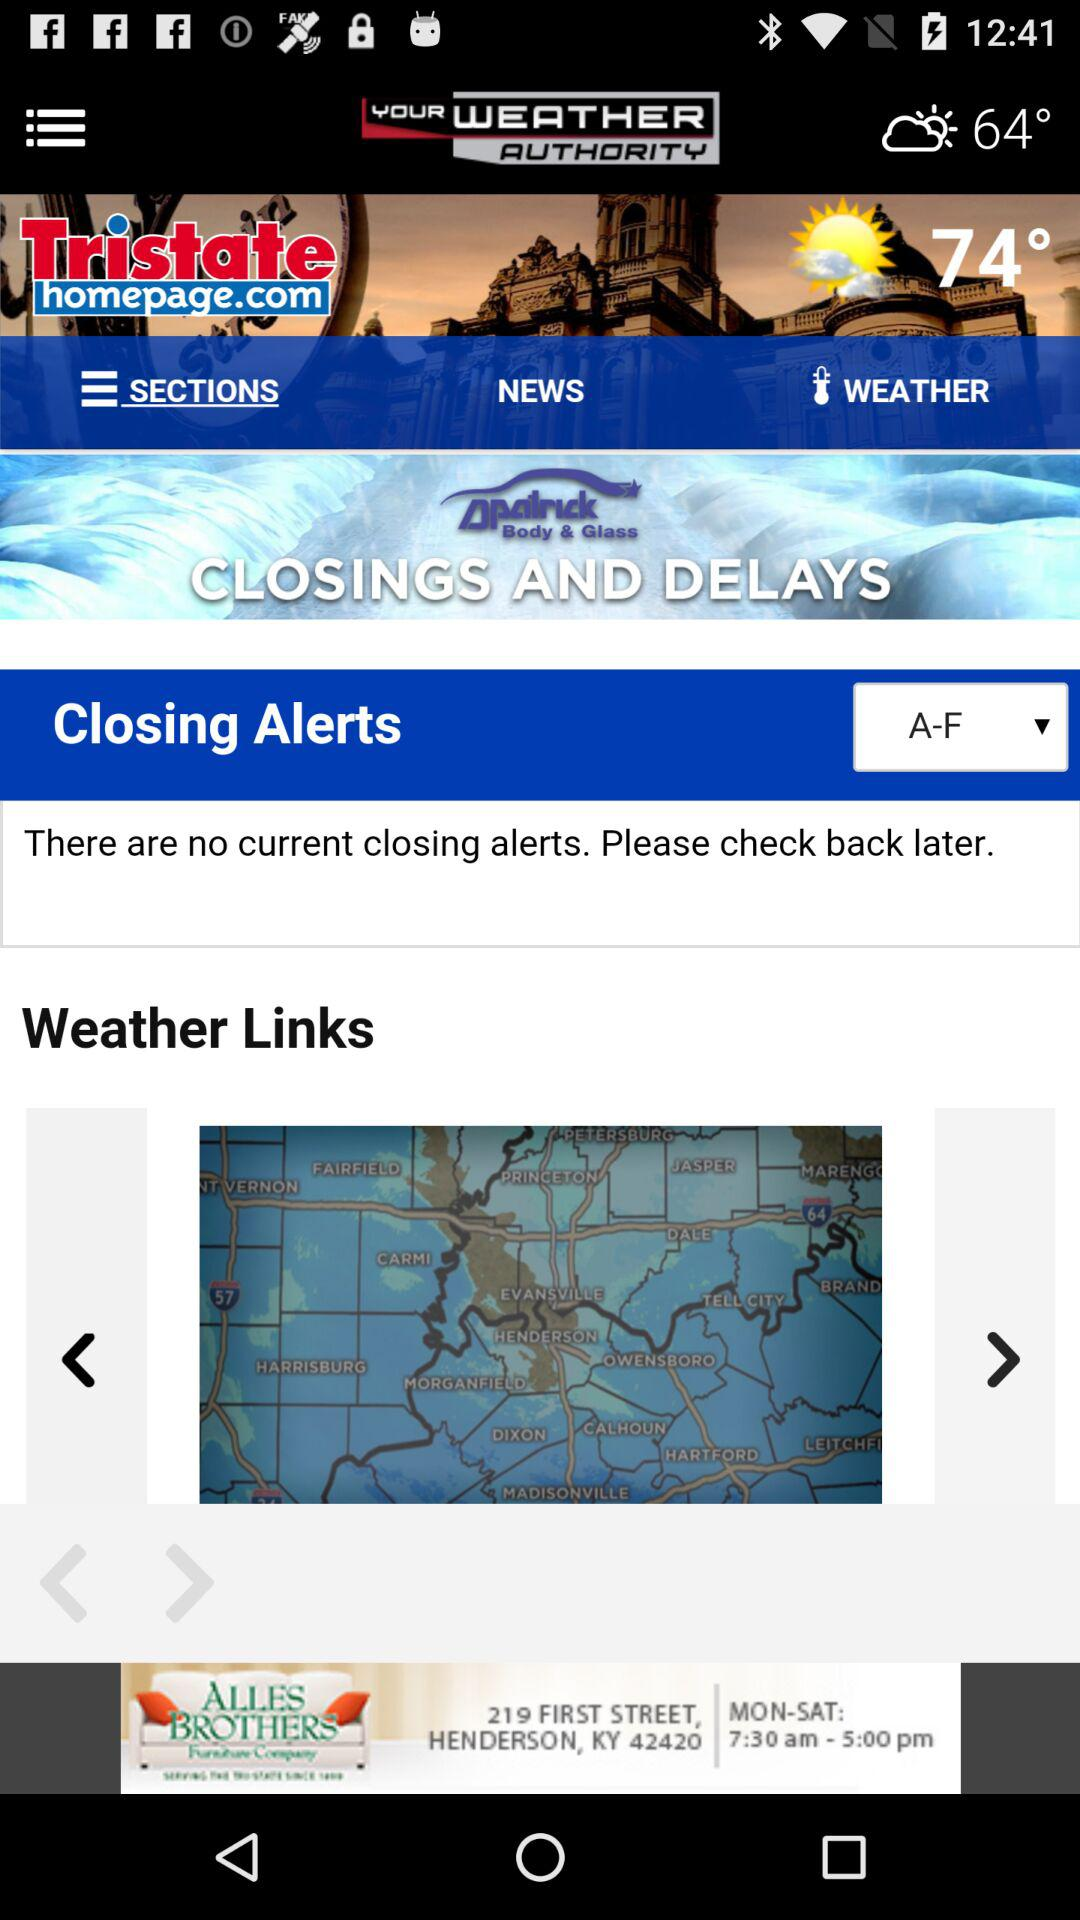What is the application name? The application name is "Tristate Weather - WEHT WTVW". 